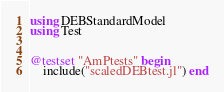Convert code to text. <code><loc_0><loc_0><loc_500><loc_500><_Julia_>using DEBStandardModel
using Test


@testset "AmPtests" begin 
    include("scaledDEBtest.jl") end</code> 